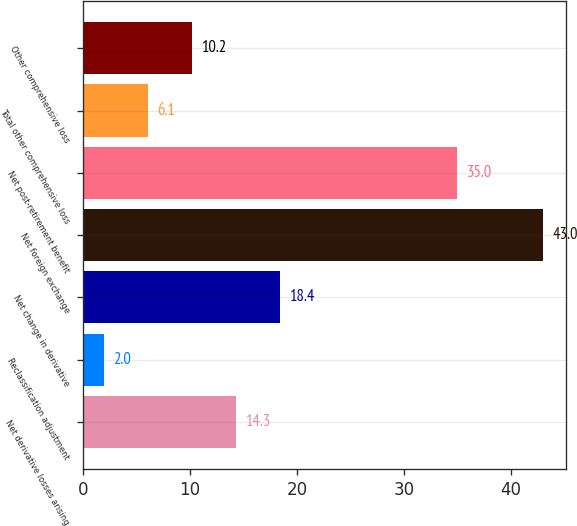Convert chart. <chart><loc_0><loc_0><loc_500><loc_500><bar_chart><fcel>Net derivative losses arising<fcel>Reclassification adjustment<fcel>Net change in derivative<fcel>Net foreign exchange<fcel>Net post-retirement benefit<fcel>Total other comprehensive loss<fcel>Other comprehensive loss<nl><fcel>14.3<fcel>2<fcel>18.4<fcel>43<fcel>35<fcel>6.1<fcel>10.2<nl></chart> 